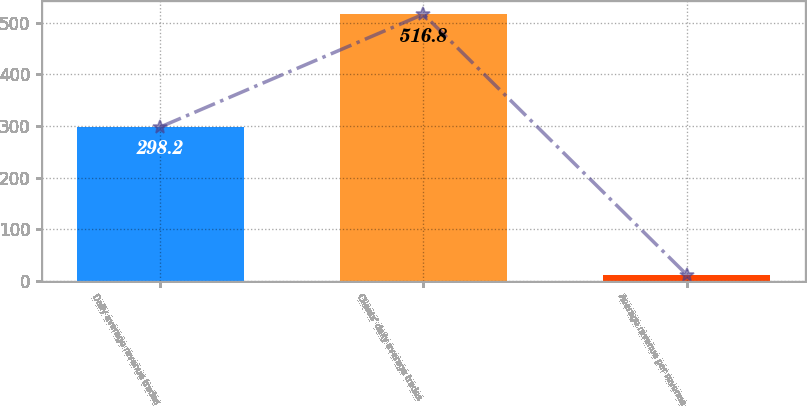Convert chart to OTSL. <chart><loc_0><loc_0><loc_500><loc_500><bar_chart><fcel>Daily average revenue trades<fcel>Clients' daily average trades<fcel>Average revenue per revenue<nl><fcel>298.2<fcel>516.8<fcel>12.13<nl></chart> 